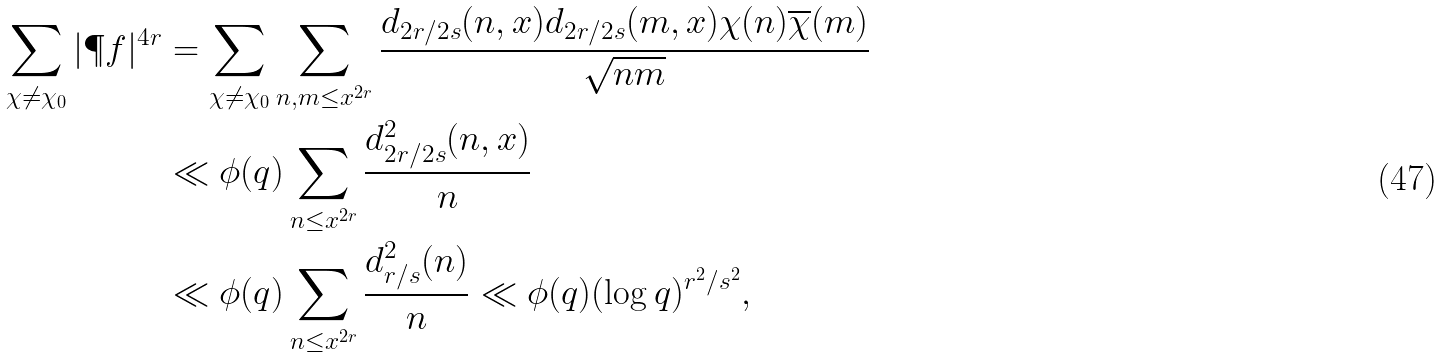Convert formula to latex. <formula><loc_0><loc_0><loc_500><loc_500>\sum _ { \chi \neq \chi _ { 0 } } | \P f | ^ { 4 r } & = \sum _ { \chi \neq \chi _ { 0 } } \sum _ { n , m \leq x ^ { 2 r } } \frac { d _ { 2 r / 2 s } ( n , x ) d _ { 2 r / 2 s } ( m , x ) \chi ( n ) \overline { \chi } ( m ) } { \sqrt { n m } } \\ & \ll \phi ( q ) \sum _ { n \leq x ^ { 2 r } } \frac { d _ { 2 r / 2 s } ^ { 2 } ( n , x ) } { n } \\ & \ll \phi ( q ) \sum _ { n \leq x ^ { 2 r } } \frac { d _ { r / s } ^ { 2 } ( n ) } { n } \ll \phi ( q ) ( \log q ) ^ { r ^ { 2 } / s ^ { 2 } } ,</formula> 